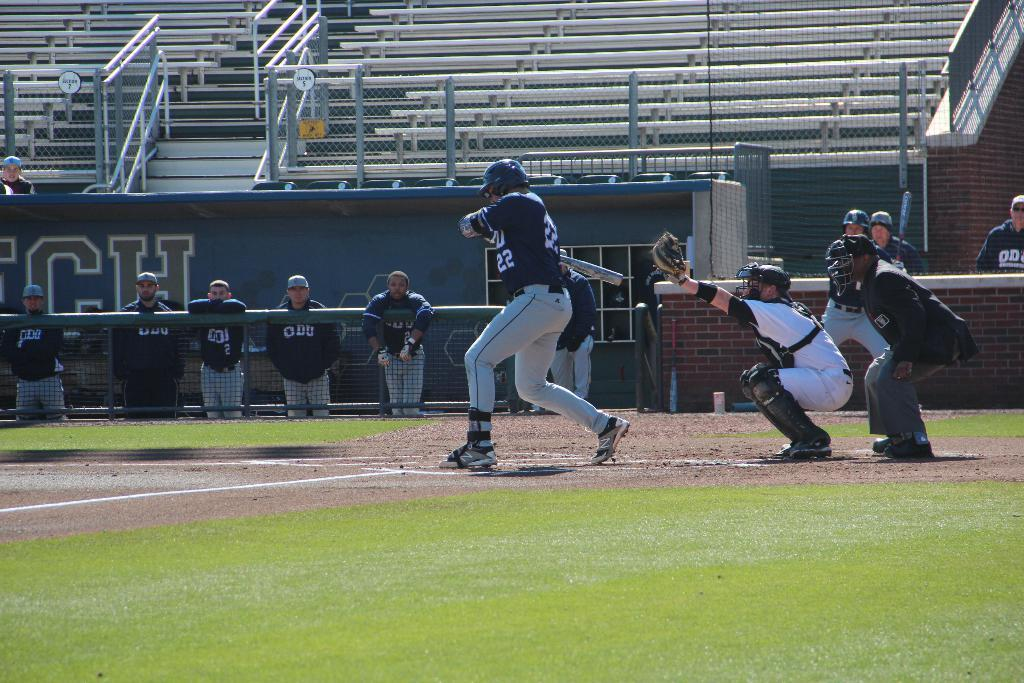<image>
Relay a brief, clear account of the picture shown. a baseball field with  number 22 at bat 